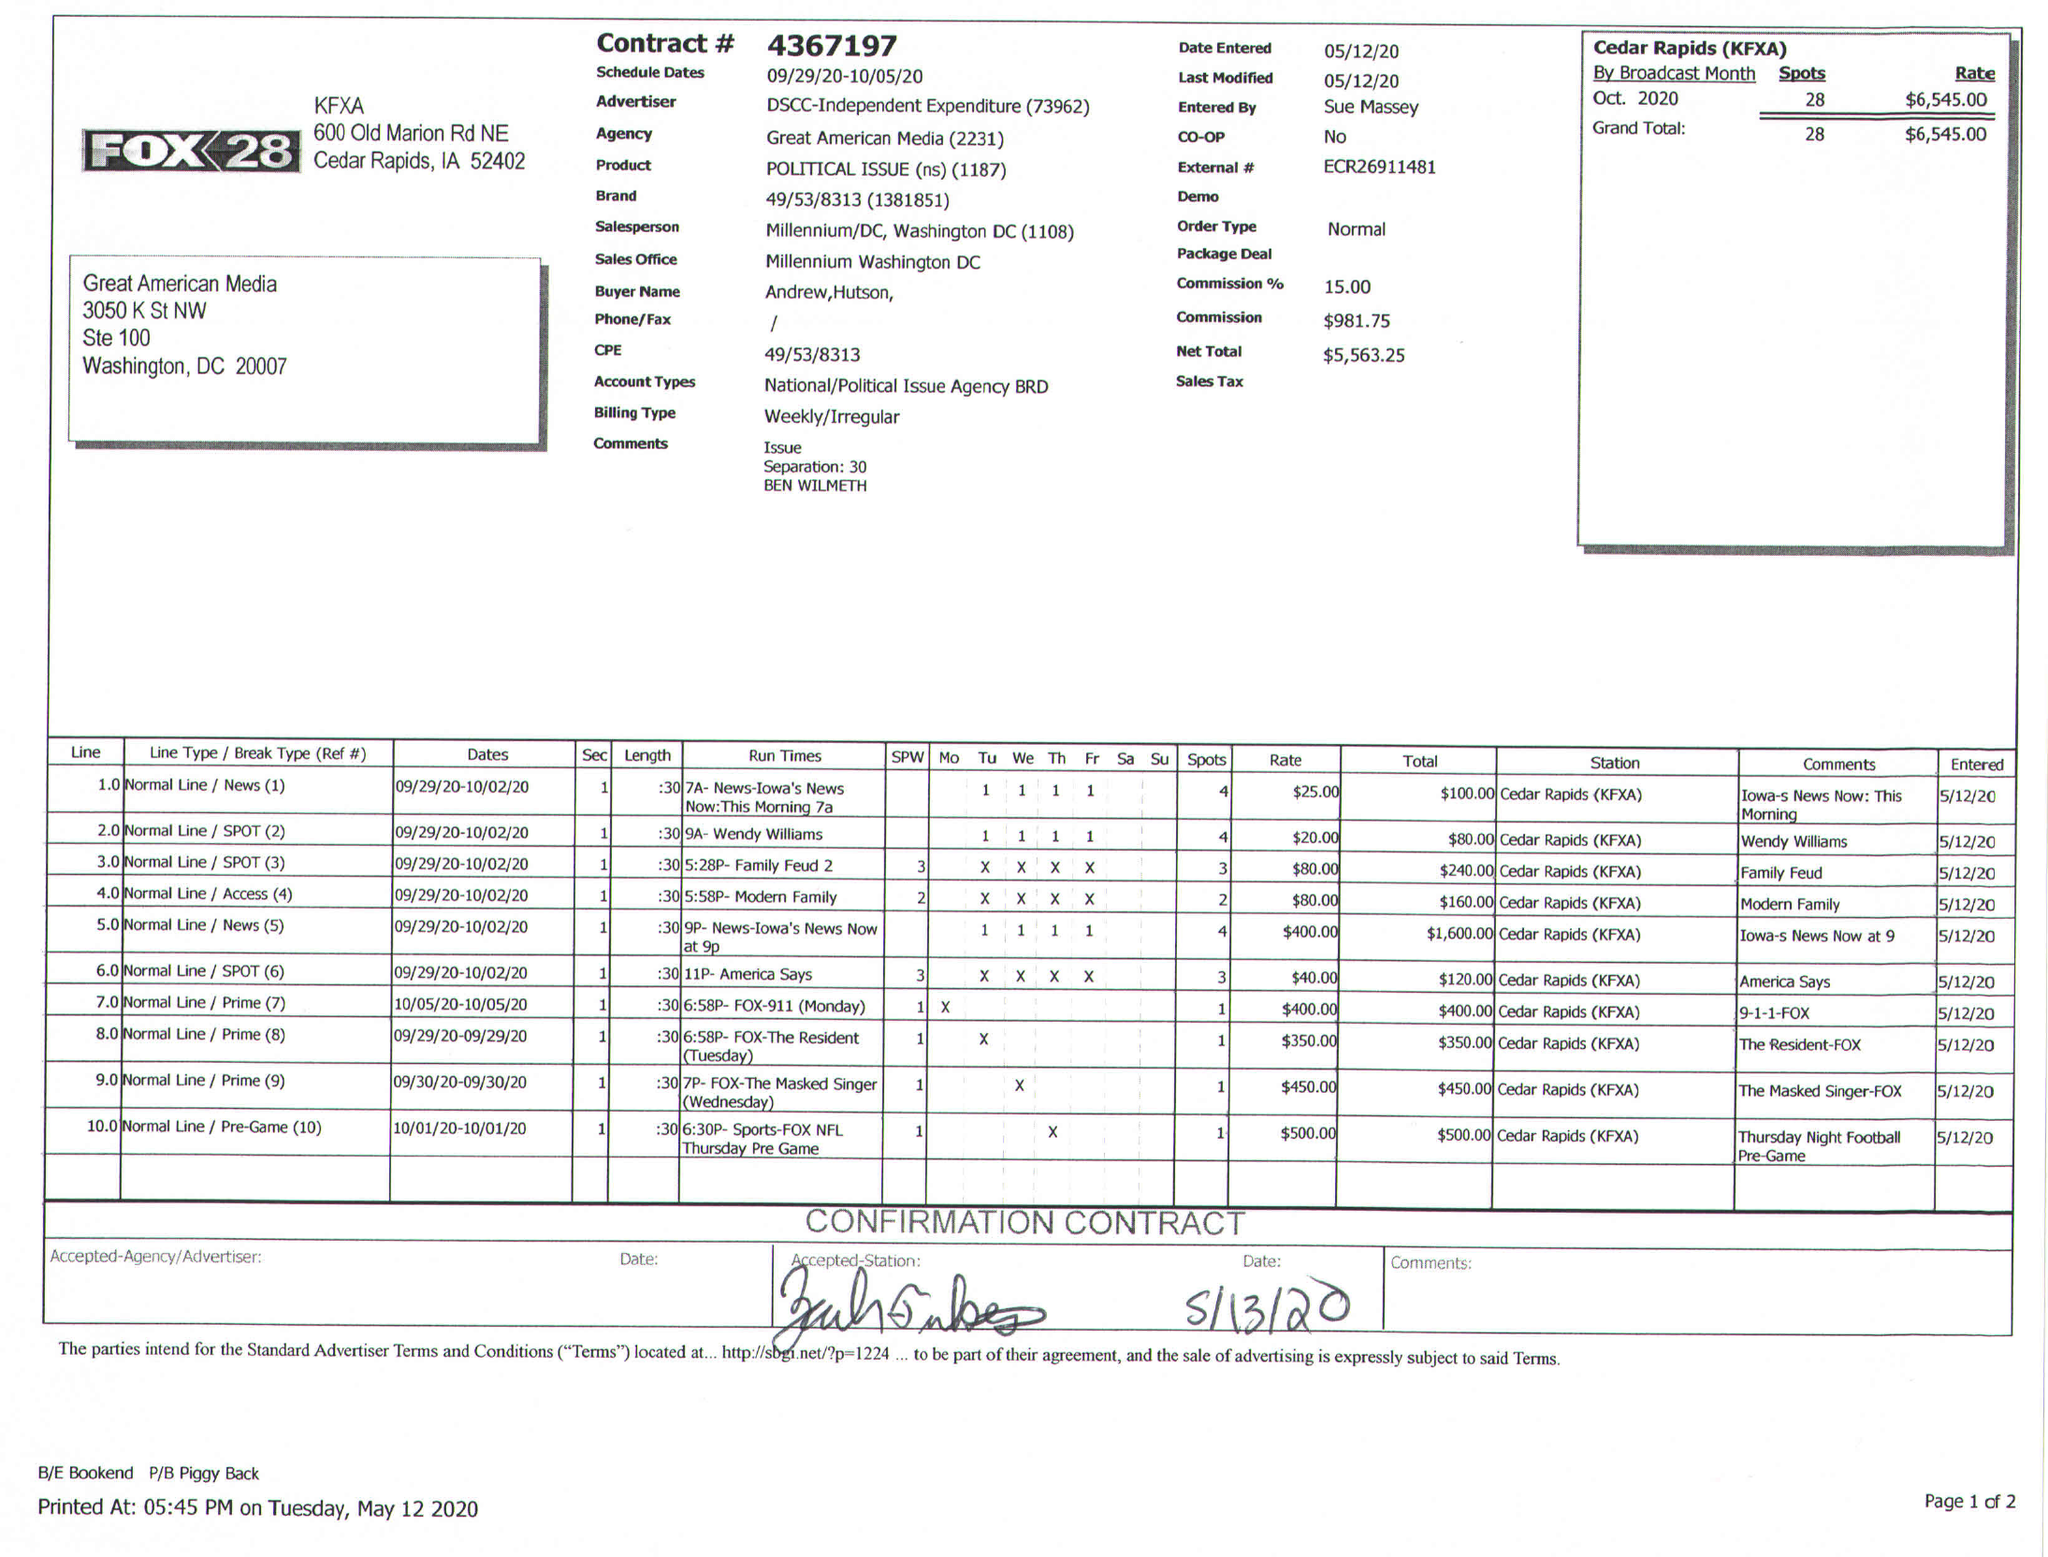What is the value for the gross_amount?
Answer the question using a single word or phrase. 6545.00 